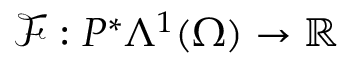<formula> <loc_0><loc_0><loc_500><loc_500>\mathcal { F } \colon P ^ { \ast } \Lambda ^ { 1 } ( \Omega ) \to \mathbb { R }</formula> 